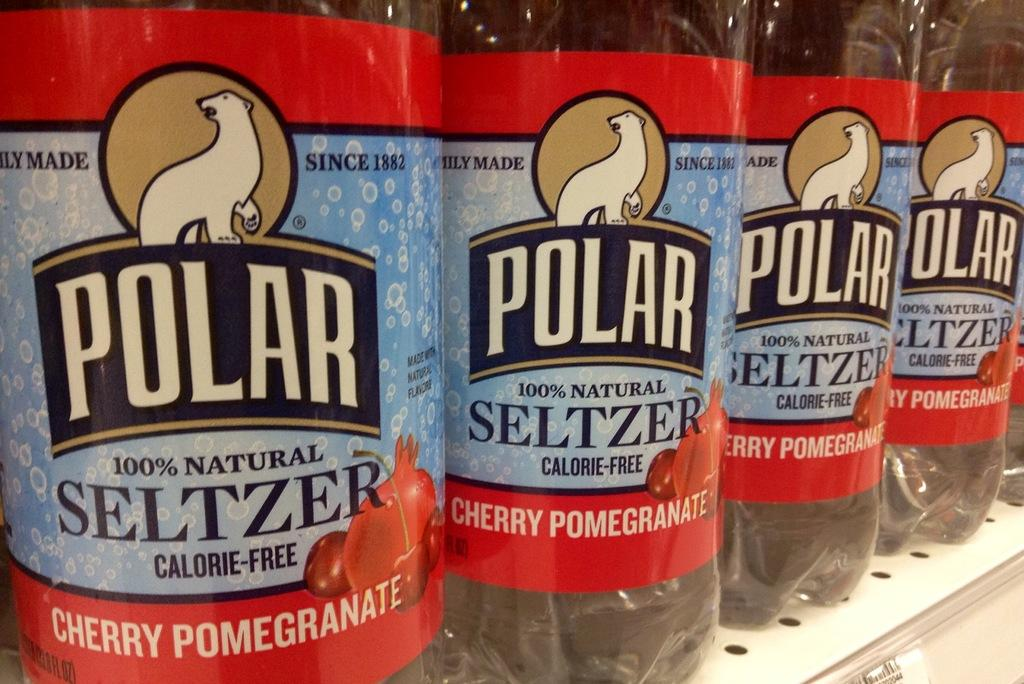<image>
Render a clear and concise summary of the photo. A row of cherry pomegranate flavored Polar brand seltzer water. 